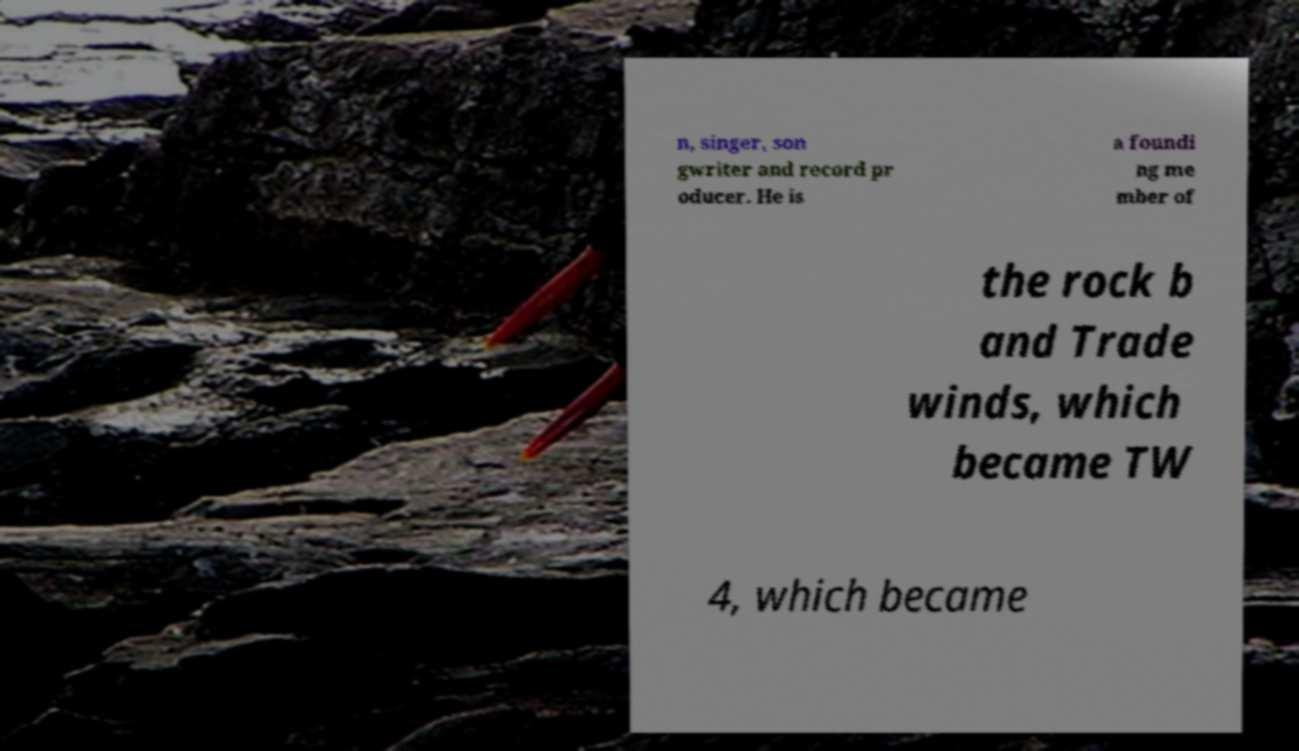Could you extract and type out the text from this image? n, singer, son gwriter and record pr oducer. He is a foundi ng me mber of the rock b and Trade winds, which became TW 4, which became 